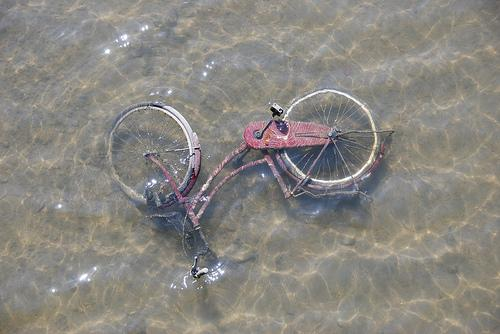Question: where is this scene?
Choices:
A. Beach.
B. Lake.
C. River.
D. Close to the water.
Answer with the letter. Answer: D Question: what is the bike in?
Choices:
A. Truck.
B. Water.
C. Van.
D. A garage.
Answer with the letter. Answer: B Question: how is the photo?
Choices:
A. Fuzzy.
B. Out of focus.
C. Good.
D. Clear.
Answer with the letter. Answer: D Question: who is present?
Choices:
A. A family.
B. The class.
C. A neighbor.
D. No one.
Answer with the letter. Answer: D Question: what is wavy?
Choices:
A. Ice.
B. Water.
C. Sand.
D. Snow.
Answer with the letter. Answer: B 